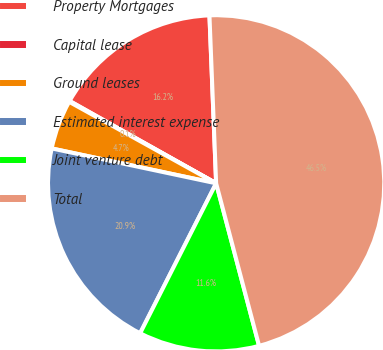<chart> <loc_0><loc_0><loc_500><loc_500><pie_chart><fcel>Property Mortgages<fcel>Capital lease<fcel>Ground leases<fcel>Estimated interest expense<fcel>Joint venture debt<fcel>Total<nl><fcel>16.22%<fcel>0.09%<fcel>4.73%<fcel>20.86%<fcel>11.58%<fcel>46.52%<nl></chart> 